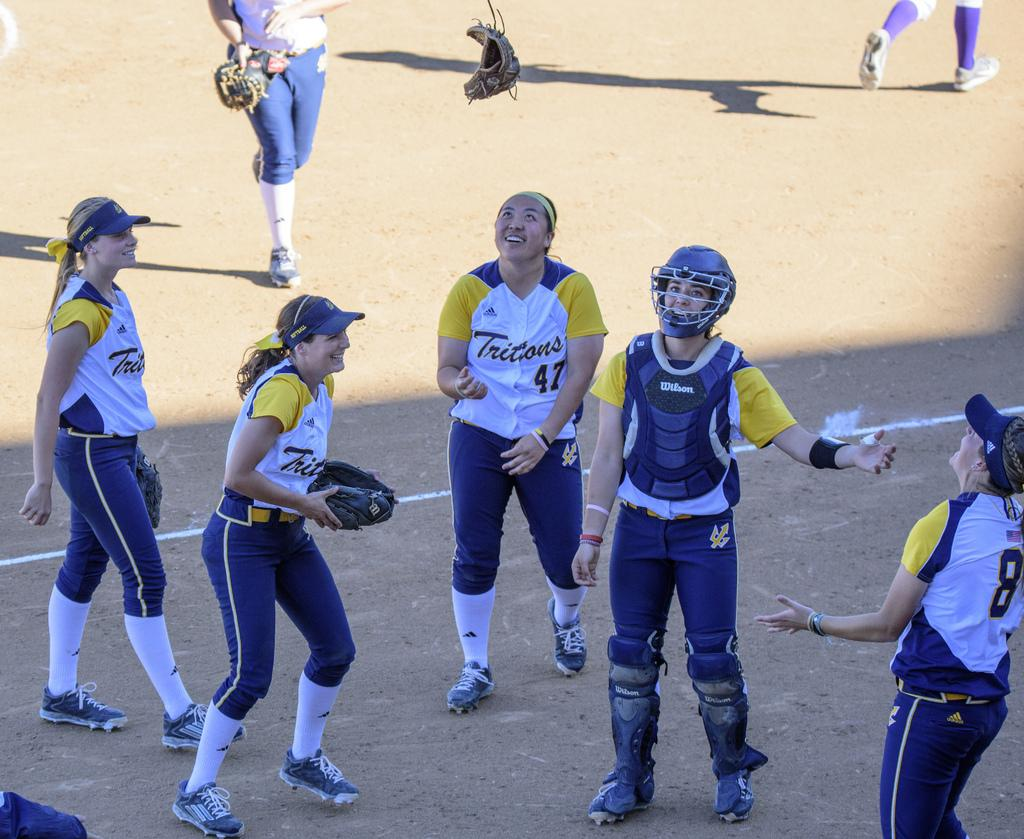<image>
Give a short and clear explanation of the subsequent image. A team called the Tritons are gathered and talking on the field. 